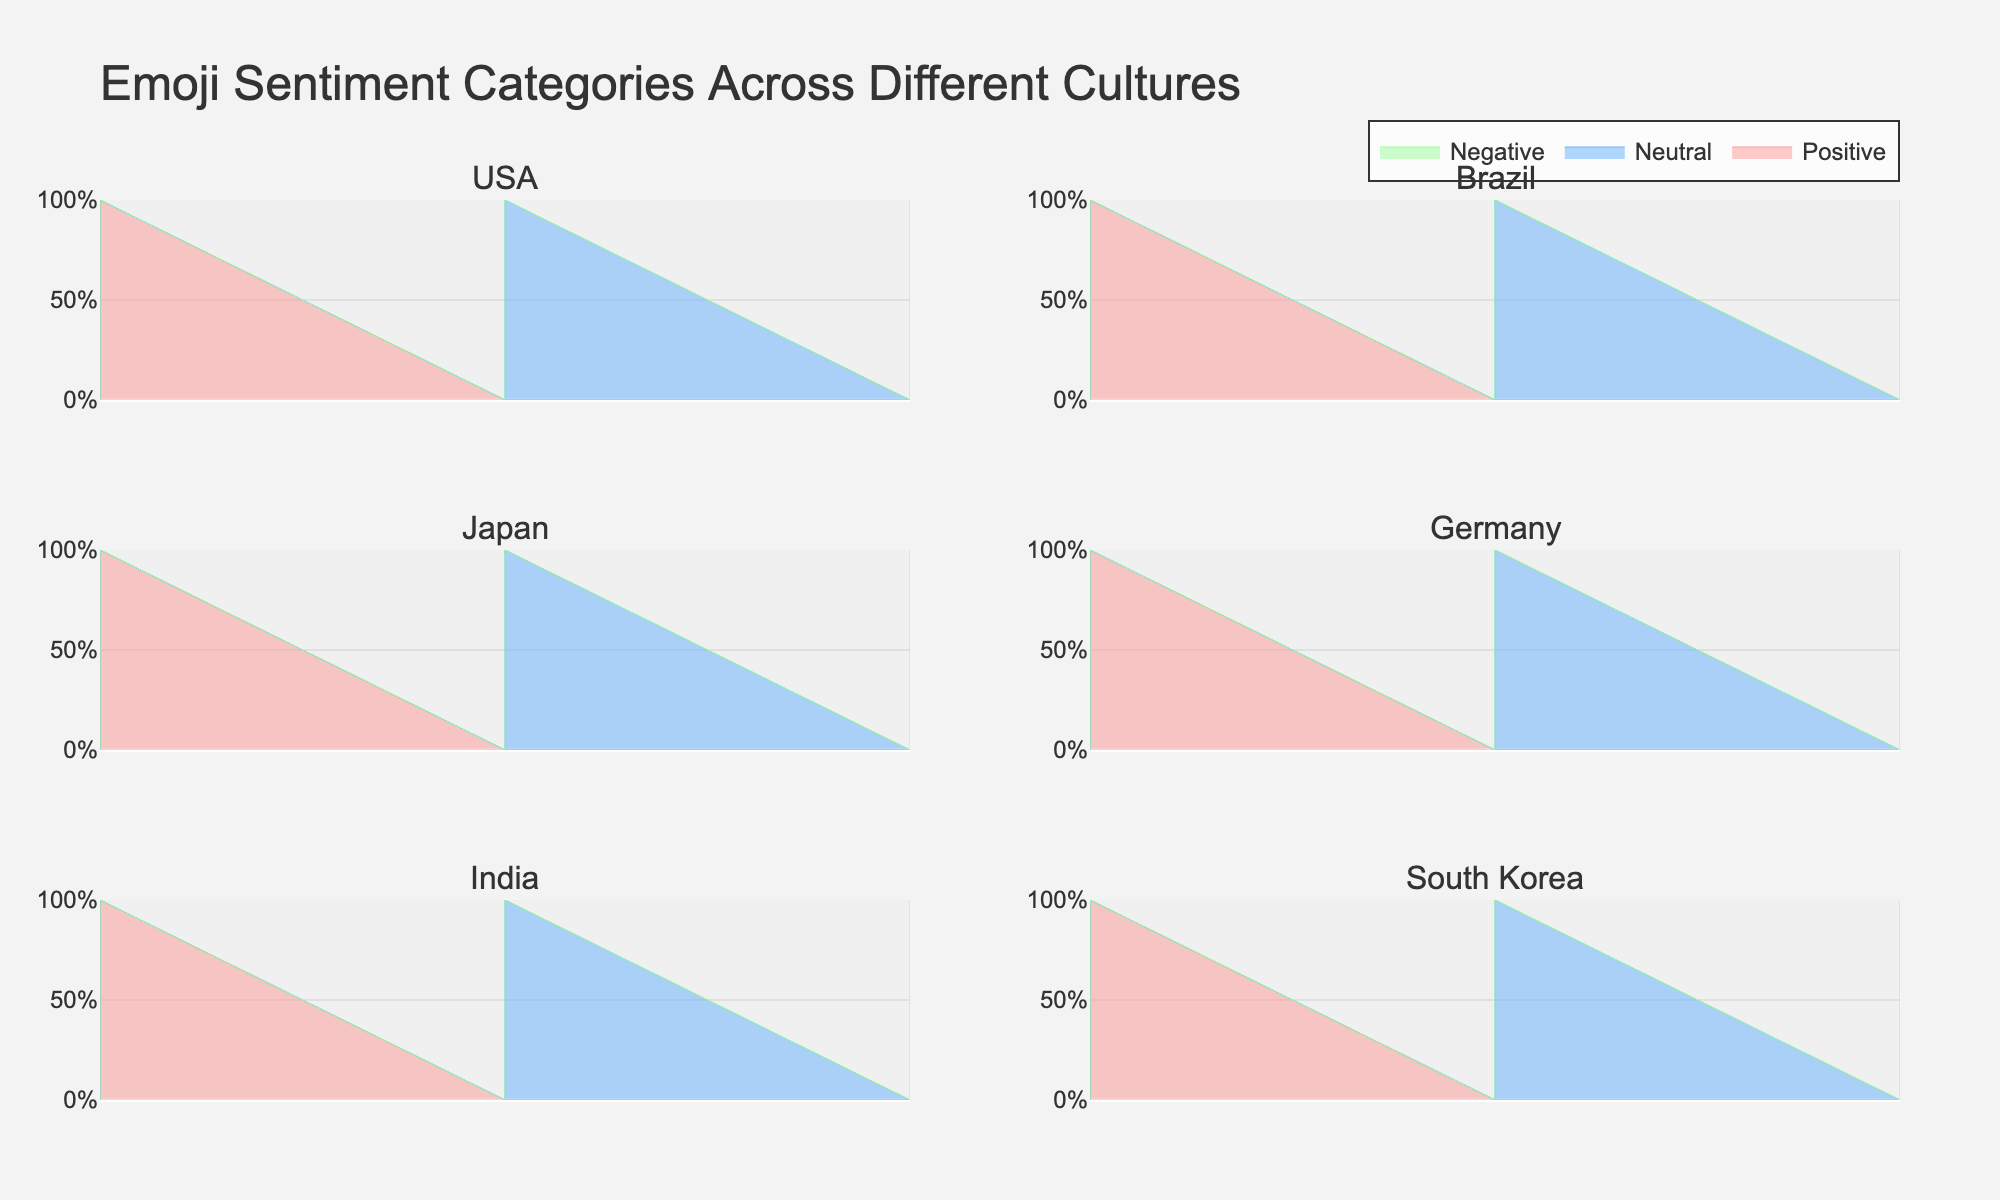Which country has the highest percentage of positive emoji sentiment? The subplots show various countries' emoji sentiment data. By checking the "Positive" percentage bars, we can see that India has the highest percentage at 60%.
Answer: India Which country has the most evenly distributed emoji sentiment categories? South Korea's subplot shows that Positive and Neutral sentiments both have 40%, making its sentiment distribution the most balanced compared to other countries.
Answer: South Korea How much greater is Brazil's positive sentiment compared to Germany's negative sentiment? Brazil's Positive sentiment is 55%. Germany's Negative sentiment is 20%. The difference is 55% - 20% = 35%.
Answer: 35% What is the total percentage of Neutral sentiments in USA and Japan combined? The USA has 30% Neutral and Japan has 35% Neutral. Adding them together, we get 30% + 35% = 65%.
Answer: 65% Which country has the lowest percentage of negative emoji sentiment? By reviewing the "Negative" sentiment bars, India shows the lowest percentage at 15%.
Answer: India In which country is the difference between Positive and Neutral sentiment percentages the largest? For each country, calculate the differences:  
USA: 45% - 30% = 15%  
Brazil: 55% - 25% = 30%  
Japan: 40% - 35% = 5%  
Germany: 50% - 30% = 20%  
India: 60% - 25% = 35%  
South Korea: 40% - 40% = 0%  
India has the largest difference with 35%.
Answer: India Compare the Negative sentiment percentages in Japan and South Korea. Both Japan and South Korea show a Negative sentiment of 25% and 20% respectively. Japan's Negative sentiment percentage is higher.
Answer: Japan What is the average percentage of Positive sentiments across all the countries? Add the Positive percentages for all the countries and divide by the number of countries:  
(45% + 55% + 40% + 50% + 60% + 40%) / 6 = 290% / 6 = ~48.33%.
Answer: ~48.33% How does USA's sentiment distribution compare to Germany's? USA: Positive (45%), Neutral (30%), Negative (25%)  
Germany: Positive (50%), Neutral (30%), Negative (20%)  
The Positive sentiment is higher in Germany by 5%. Neutral sentiment is equal. Negative sentiment is lower in Germany by 5%.
Answer: Germany has a slightly higher Positive and lower Negative sentiment while Neutral is the same 